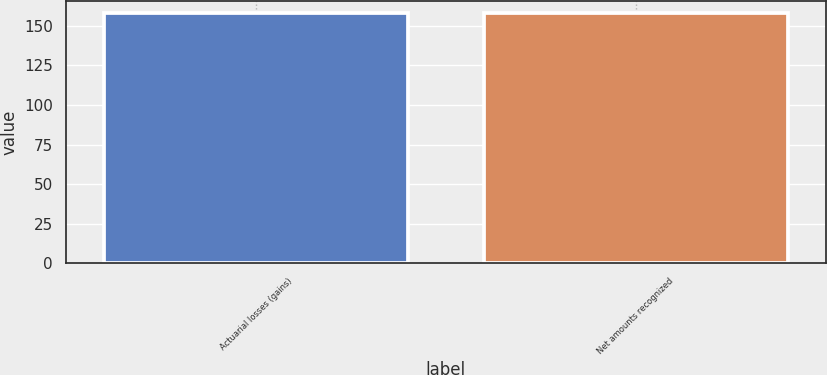<chart> <loc_0><loc_0><loc_500><loc_500><bar_chart><fcel>Actuarial losses (gains)<fcel>Net amounts recognized<nl><fcel>158<fcel>158.1<nl></chart> 